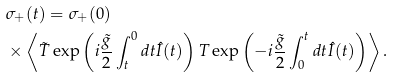Convert formula to latex. <formula><loc_0><loc_0><loc_500><loc_500>& \sigma _ { + } ( t ) = \sigma _ { + } ( 0 ) \\ & \times \left \langle \tilde { T } \exp \left ( i \frac { \tilde { g } } { 2 } \int _ { t } ^ { 0 } d t \hat { I } ( t ) \right ) T \exp \left ( - i \frac { \tilde { g } } { 2 } \int _ { 0 } ^ { t } d t \hat { I } ( t ) \right ) \right \rangle .</formula> 